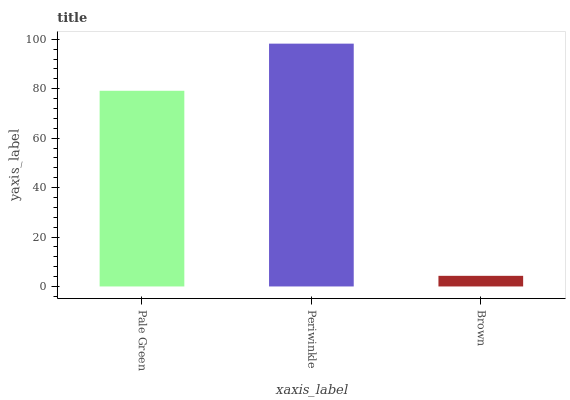Is Brown the minimum?
Answer yes or no. Yes. Is Periwinkle the maximum?
Answer yes or no. Yes. Is Periwinkle the minimum?
Answer yes or no. No. Is Brown the maximum?
Answer yes or no. No. Is Periwinkle greater than Brown?
Answer yes or no. Yes. Is Brown less than Periwinkle?
Answer yes or no. Yes. Is Brown greater than Periwinkle?
Answer yes or no. No. Is Periwinkle less than Brown?
Answer yes or no. No. Is Pale Green the high median?
Answer yes or no. Yes. Is Pale Green the low median?
Answer yes or no. Yes. Is Brown the high median?
Answer yes or no. No. Is Brown the low median?
Answer yes or no. No. 